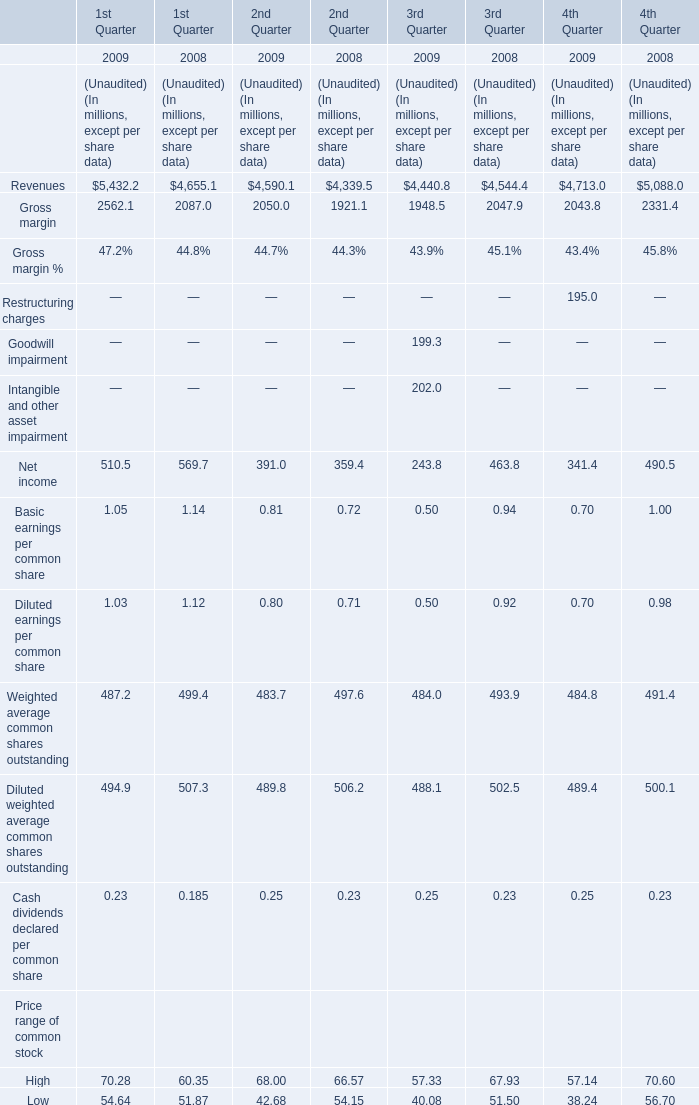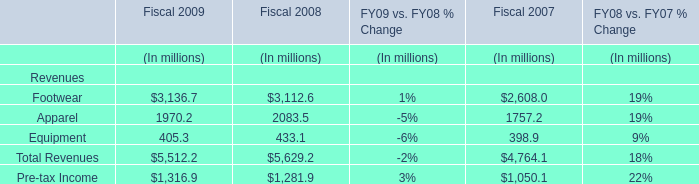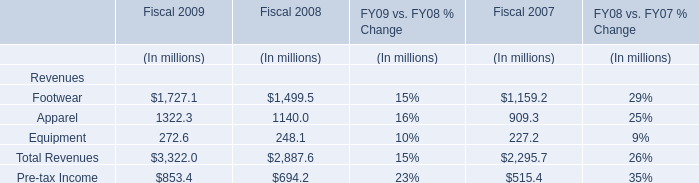What is the growing rate of Apparel for Revenues in the year with the most Net income for 1st Quarter? 
Computations: ((1970.2 - 2083.5) / 2083.5)
Answer: -0.05438. 